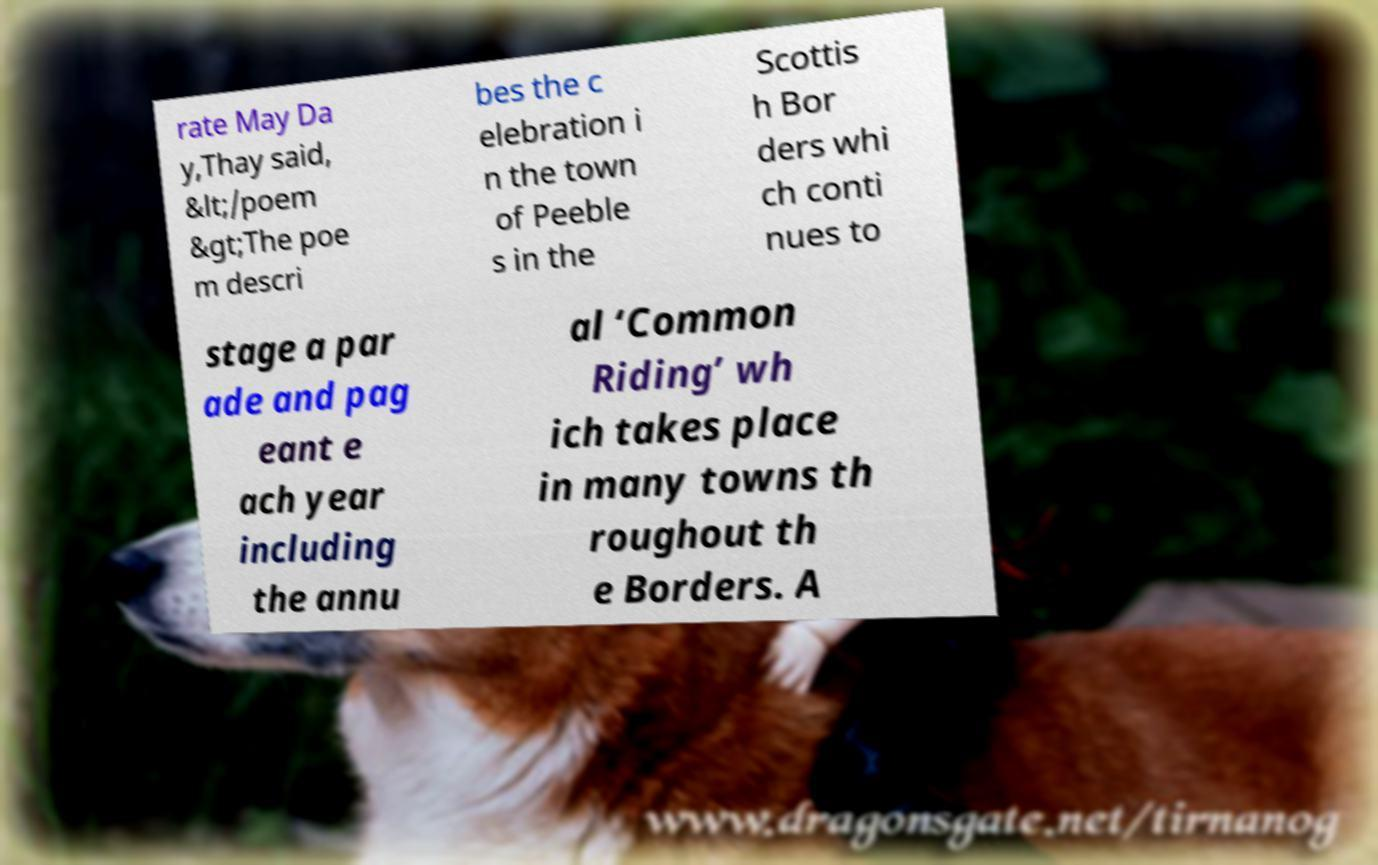Please identify and transcribe the text found in this image. rate May Da y,Thay said, &lt;/poem &gt;The poe m descri bes the c elebration i n the town of Peeble s in the Scottis h Bor ders whi ch conti nues to stage a par ade and pag eant e ach year including the annu al ‘Common Riding’ wh ich takes place in many towns th roughout th e Borders. A 